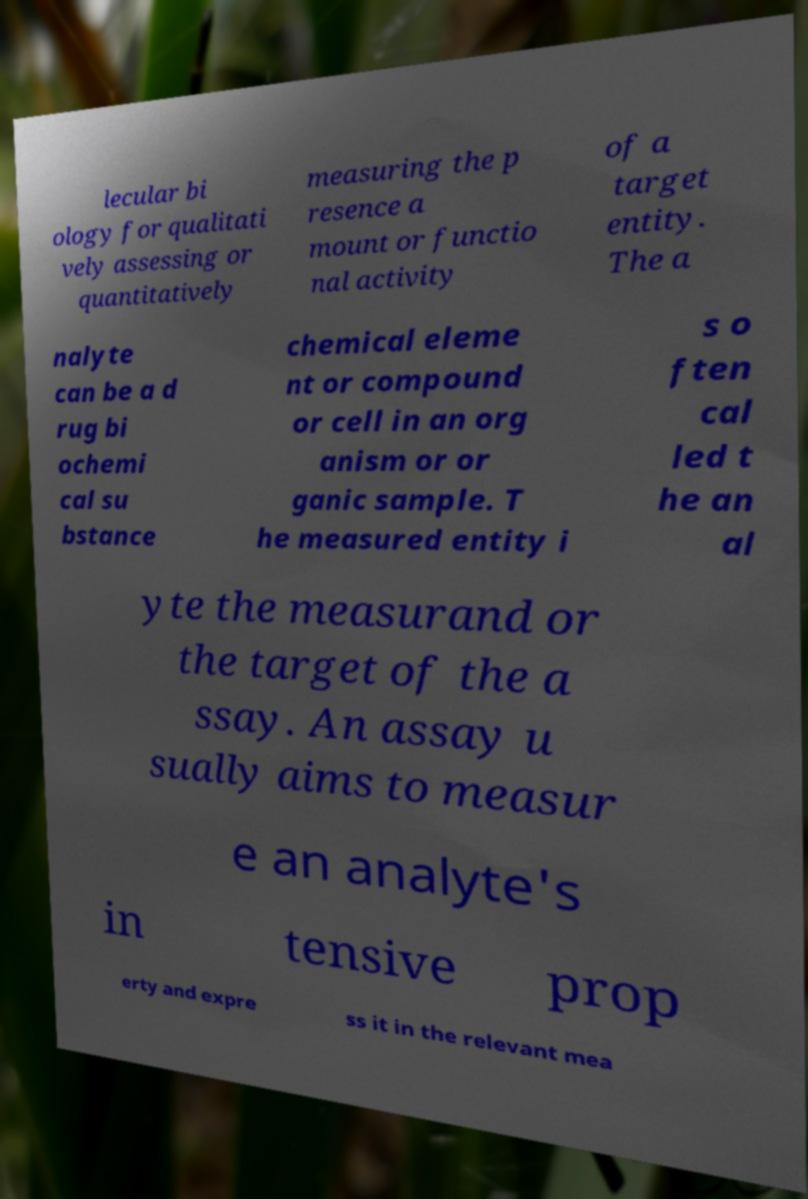What messages or text are displayed in this image? I need them in a readable, typed format. lecular bi ology for qualitati vely assessing or quantitatively measuring the p resence a mount or functio nal activity of a target entity. The a nalyte can be a d rug bi ochemi cal su bstance chemical eleme nt or compound or cell in an org anism or or ganic sample. T he measured entity i s o ften cal led t he an al yte the measurand or the target of the a ssay. An assay u sually aims to measur e an analyte's in tensive prop erty and expre ss it in the relevant mea 